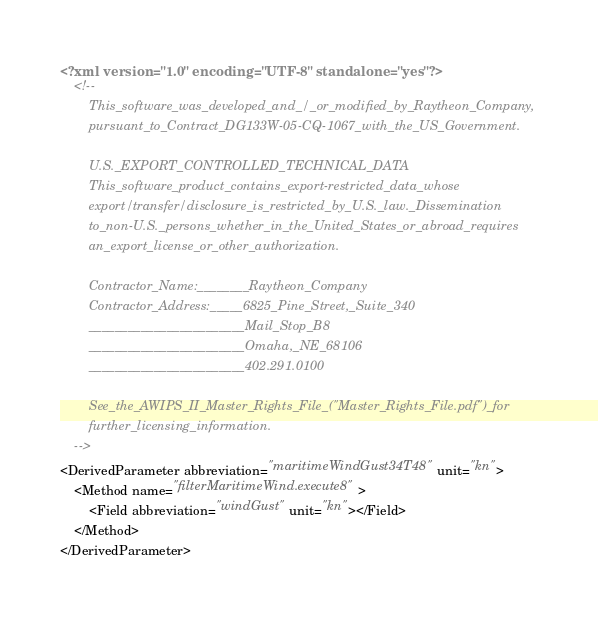<code> <loc_0><loc_0><loc_500><loc_500><_XML_><?xml version="1.0" encoding="UTF-8" standalone="yes"?>
    <!--
        This_software_was_developed_and_/_or_modified_by_Raytheon_Company,
        pursuant_to_Contract_DG133W-05-CQ-1067_with_the_US_Government.
        
        U.S._EXPORT_CONTROLLED_TECHNICAL_DATA
        This_software_product_contains_export-restricted_data_whose
        export/transfer/disclosure_is_restricted_by_U.S._law._Dissemination
        to_non-U.S._persons_whether_in_the_United_States_or_abroad_requires
        an_export_license_or_other_authorization.
        
        Contractor_Name:________Raytheon_Company
        Contractor_Address:_____6825_Pine_Street,_Suite_340
        ________________________Mail_Stop_B8
        ________________________Omaha,_NE_68106
        ________________________402.291.0100
        
        See_the_AWIPS_II_Master_Rights_File_("Master_Rights_File.pdf")_for
        further_licensing_information.
    -->
<DerivedParameter abbreviation="maritimeWindGust34T48" unit="kn">
    <Method name="filterMaritimeWind.execute8">
        <Field abbreviation="windGust" unit="kn"></Field>
    </Method>
</DerivedParameter>
</code> 